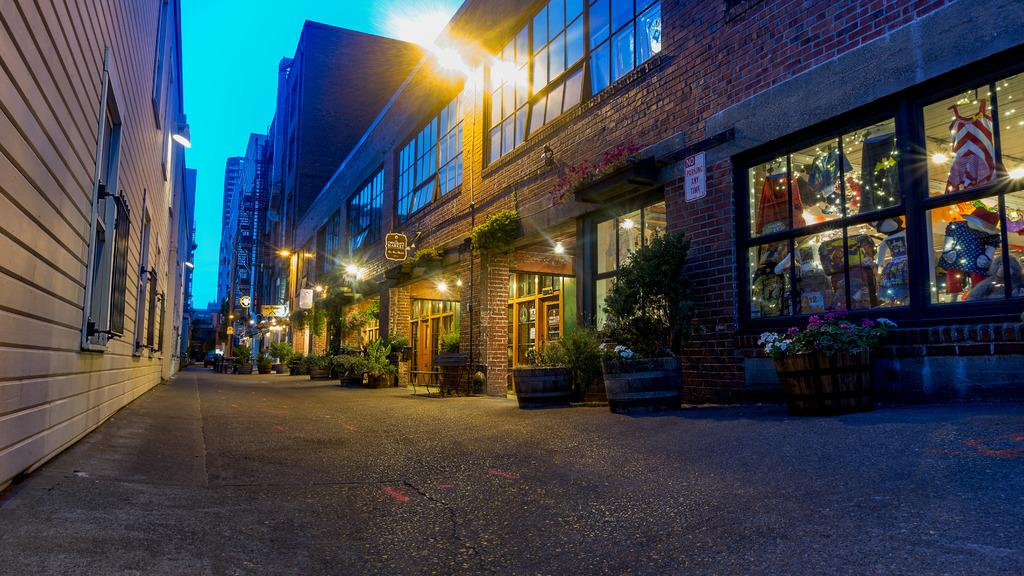What type of structures can be seen in the image? There are buildings in the image. What can be seen illuminating the scene in the image? There are lights in the image. What type of vegetation is present in the image? There are plants in the image. What type of signage can be seen in the image? There are boards in the image. What type of access points are visible in the buildings? There are doors in the image. What type of openings are visible in the buildings? There are windows in the image. What type of pathway is present in the image? There is a road in the image. What type of personal items can be seen in the image? There are clothes in the image. What can be seen in the background of the image? The sky is visible in the background of the image. Can you tell me how many sticks of butter are on the clothes in the image? There is no butter present in the image; it features buildings, lights, plants, boards, doors, windows, a road, and clothes. What type of animal's nose can be seen on the road in the image? There are no animal noses present in the image; it features buildings, lights, plants, boards, doors, windows, a road, and clothes. 